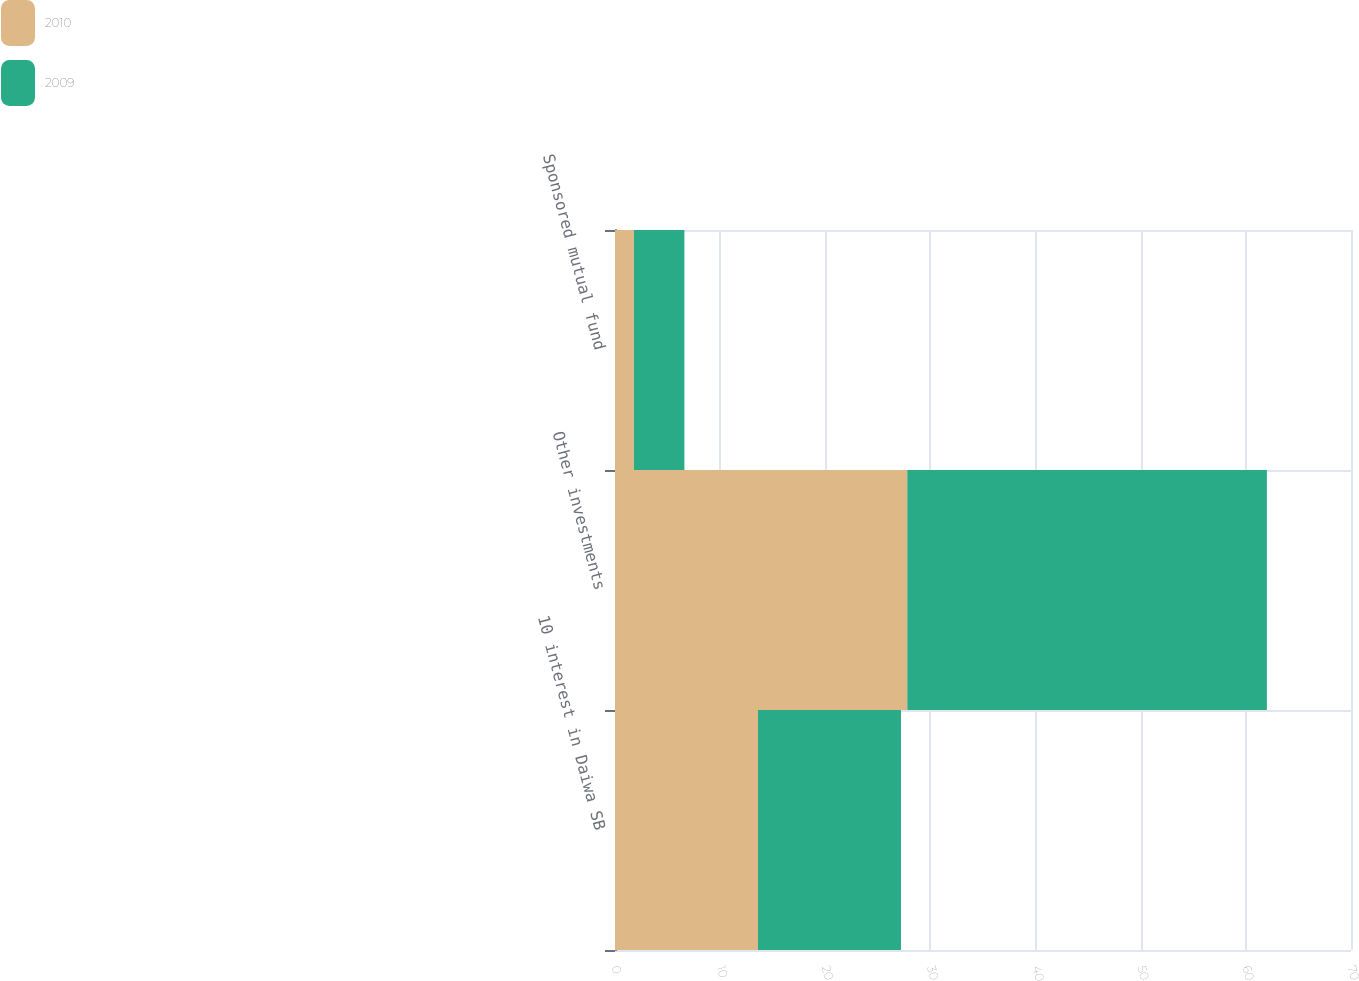Convert chart. <chart><loc_0><loc_0><loc_500><loc_500><stacked_bar_chart><ecel><fcel>10 interest in Daiwa SB<fcel>Other investments<fcel>Sponsored mutual fund<nl><fcel>2010<fcel>13.6<fcel>27.8<fcel>1.8<nl><fcel>2009<fcel>13.6<fcel>34.2<fcel>4.8<nl></chart> 